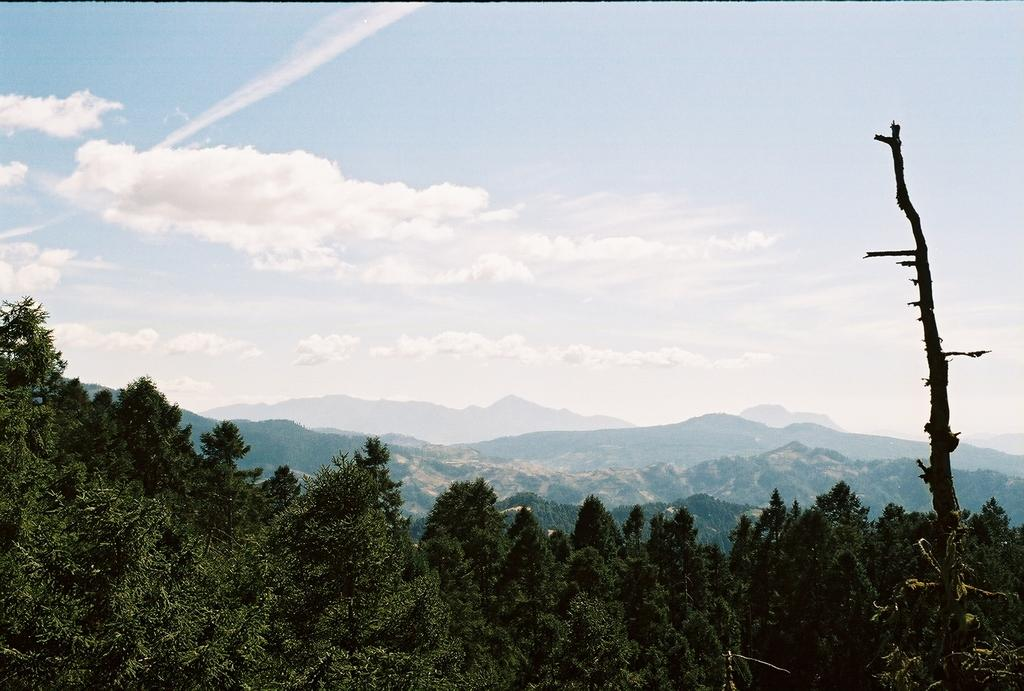What type of vegetation can be seen in the image? There are trees in the image. What geographical features are present in the image? There are hills in the image. What can be seen in the background of the image? The sky is visible in the background of the image. Can you see any pigs in the image? There are no pigs present in the image; it features trees and hills with a visible sky in the background. 